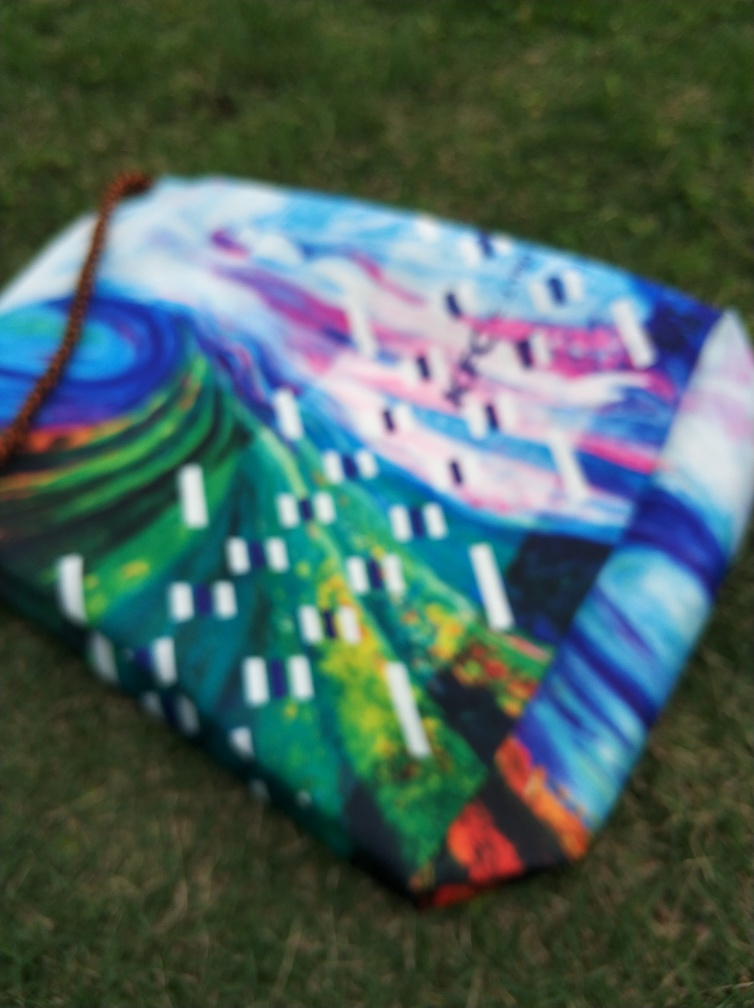Can you guess what style of art this is? Based on the discernible elements within the blur, the art style appears to be abstract, characterized by vibrant colors and perhaps non-representational forms. Why might someone take a photo like this? The photo could have been taken this way to evoke a sense of mystery or focus on the overall color palette and emotional impact rather than the details of the artwork. 